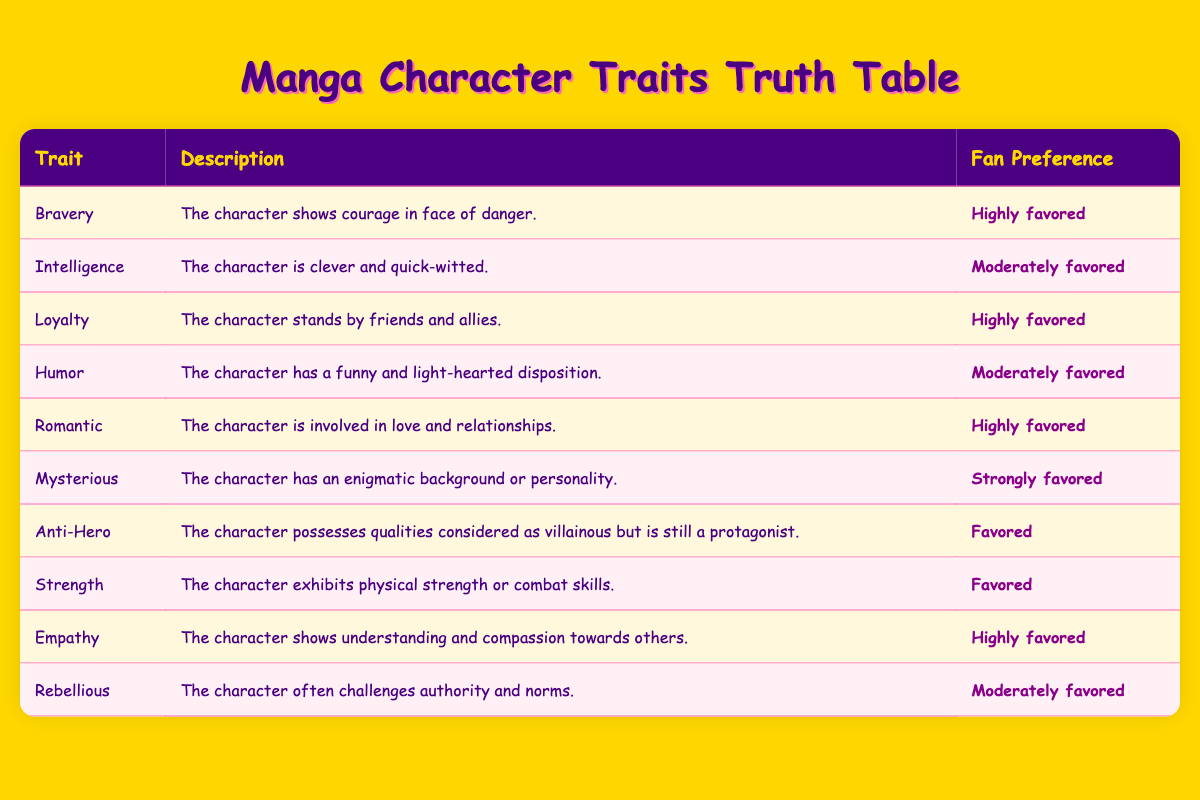What is the fan preference for characters who exhibit bravery? The table shows that bravery as a trait is labeled with a fan preference of "Highly favored".
Answer: Highly favored Which character trait is described as having an enigmatic background? The trait that describes a character with an enigmatic background or personality is "Mysterious", which has a fan preference of "Strongly favored".
Answer: Strongly favored How many traits are highly favored? Observing the table, the traits listed with "Highly favored" are Bravery, Loyalty, Romantic, and Empathy, totaling four traits.
Answer: Four Is empathy favored more than humor? Comparing the preferences, empathy has a fan preference of "Highly favored," while humor is "Moderately favored," indicating empathy is favored more.
Answer: Yes If we were to sum the preferences for all traits, how many would be favored versus moderately favored? Examining the table, there are 2 traits listed as favored (Anti-Hero, Strength), 4 traits as moderately favored (Intelligence, Humor, Rebellious), 4 as highly favored (Bravery, Loyalty, Romantic, Empathy), and 1 strongly favored (Mysterious). The result shows a total of 2 favored and 4 moderately favored.
Answer: 2 favored, 4 moderately favored What trait has a stronger preference: mysterious or anti-hero? The trait "Mysterious" has a fan preference of "Strongly favored," while "Anti-Hero" is just "Favored," so mysterious has the stronger preference.
Answer: Mysterious Which trait has the least fan preference? The traits "Anti-Hero" and "Strength" both share the fan preference of "Favored," but they are not the least; "Humor," "Rebellious," and "Intelligence" are "Moderately favored," so these all have the least preference level noted in the table.
Answer: Humor, Rebellious, Intelligence Are there any traits that relate to romantic themes that are moderately favored? The table indicates that "Romantic" is highly favored, while no traits related to romance are specifically moderately favored; thus, the answer is no.
Answer: No Which fan preference is the most common among the traits listed? By examining the table, we see four traits marked as "Highly favored", making this the most common preference in the data provided.
Answer: Highly favored 